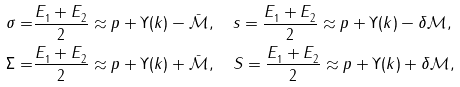<formula> <loc_0><loc_0><loc_500><loc_500>\sigma = & \frac { E _ { 1 } ^ { } + E _ { 2 } ^ { } } { 2 } \approx p + \Upsilon ( k ) - \bar { \mathcal { M } } , \quad s = \frac { E _ { 1 } ^ { } + E _ { 2 } ^ { } } { 2 } \approx p + \Upsilon ( k ) - \delta \mathcal { M } , \\ \Sigma = & \frac { E _ { 1 } ^ { } + E _ { 2 } ^ { } } { 2 } \approx p + \Upsilon ( k ) + \bar { \mathcal { M } } , \quad S = \frac { E _ { 1 } ^ { } + E _ { 2 } ^ { } } { 2 } \approx p + \Upsilon ( k ) + \delta \mathcal { M } ,</formula> 